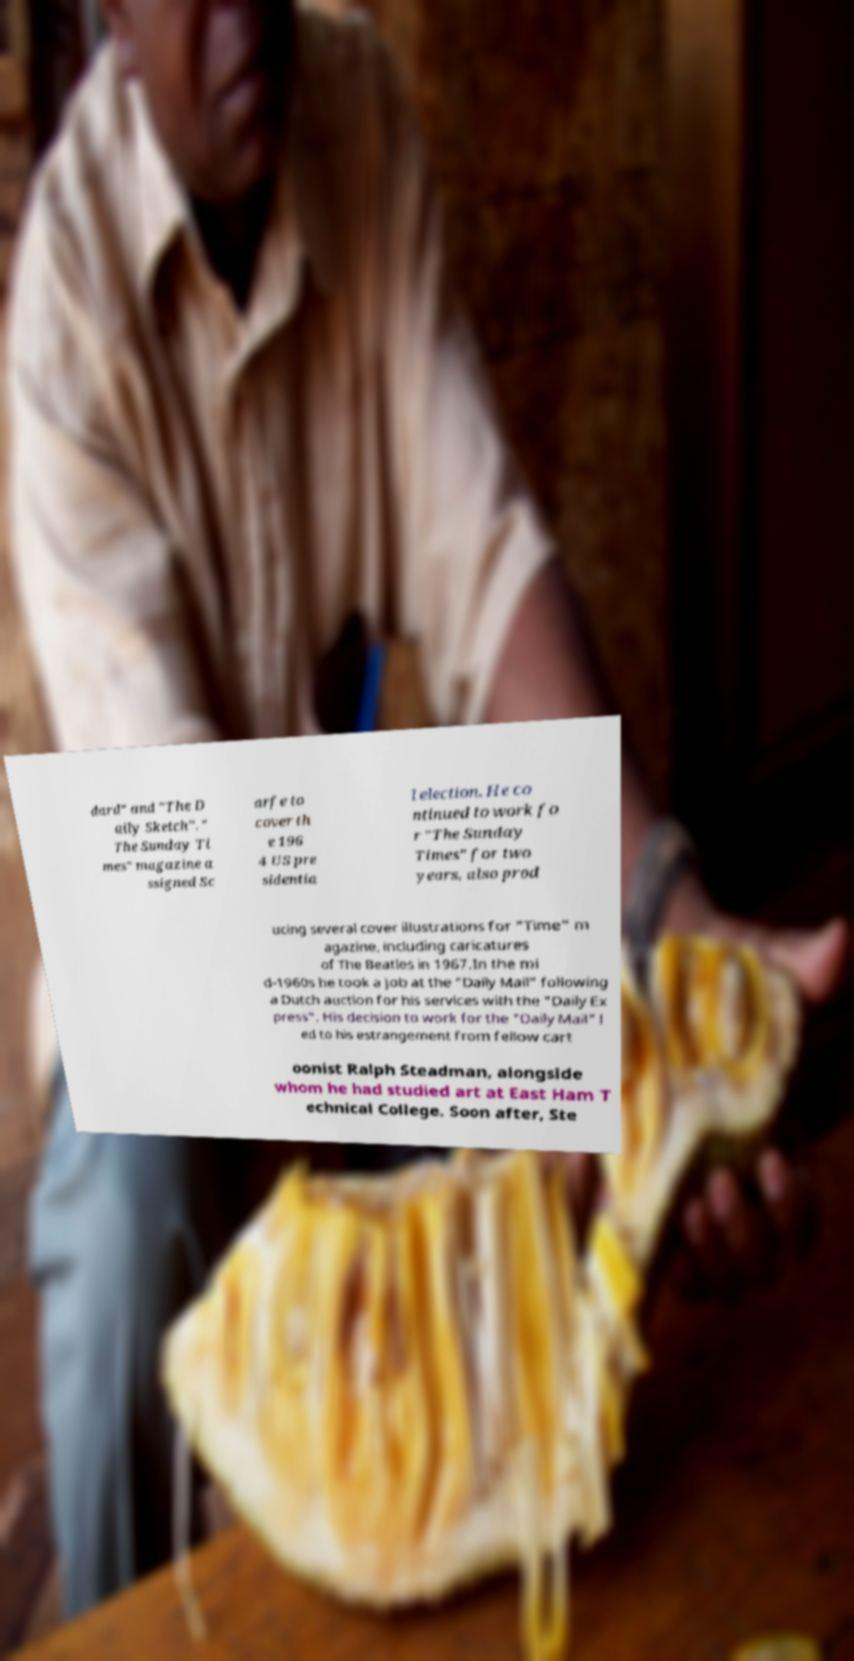There's text embedded in this image that I need extracted. Can you transcribe it verbatim? dard" and "The D aily Sketch". " The Sunday Ti mes" magazine a ssigned Sc arfe to cover th e 196 4 US pre sidentia l election. He co ntinued to work fo r "The Sunday Times" for two years, also prod ucing several cover illustrations for "Time" m agazine, including caricatures of The Beatles in 1967.In the mi d-1960s he took a job at the "Daily Mail" following a Dutch auction for his services with the "Daily Ex press". His decision to work for the "Daily Mail" l ed to his estrangement from fellow cart oonist Ralph Steadman, alongside whom he had studied art at East Ham T echnical College. Soon after, Ste 